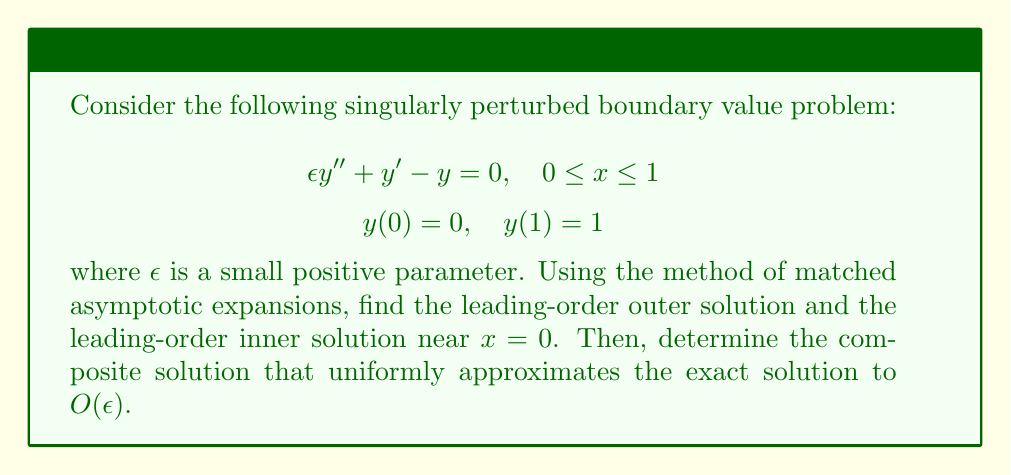What is the answer to this math problem? To solve this problem using matched asymptotic expansions, we'll follow these steps:

1) Outer solution:
Set $\epsilon = 0$ in the original equation to get the reduced equation:
$$y' - y = 0$$
The general solution is $y_{out} = Ae^x$. Applying the boundary condition at $x = 1$:
$$y_{out}(1) = Ae^1 = 1 \implies A = e^{-1}$$
So the outer solution is:
$$y_{out} = e^{x-1}$$

2) Inner solution:
Near $x = 0$, introduce a stretched coordinate $X = x/\epsilon$. The equation becomes:
$$\frac{d^2y}{dX^2} + \frac{dy}{dX} - \epsilon y = 0$$
To leading order as $\epsilon \to 0$:
$$\frac{d^2y}{dX^2} + \frac{dy}{dX} = 0$$
The general solution is:
$$y_{in} = B + Ce^{-X}$$
Applying the boundary condition at $x = 0$ (i.e., $X = 0$):
$$y_{in}(0) = B + C = 0 \implies C = -B$$
So the inner solution is:
$$y_{in} = B(1 - e^{-X}) = B(1 - e^{-x/\epsilon})$$

3) Matching:
To determine $B$, we match the inner and outer solutions in an intermediate region where both are valid. As $X \to \infty$ (or $x/\epsilon \to \infty$):
$$y_{in} \sim B$$
As $x \to 0$:
$$y_{out} \sim e^{-1}(1 + x)$$
Matching these:
$$B = e^{-1}$$

4) Composite solution:
The composite solution is formed by adding the inner and outer solutions and subtracting their common part:
$$y_{comp} = y_{in} + y_{out} - y_{common}$$
$$= e^{-1}(1 - e^{-x/\epsilon}) + e^{x-1} - e^{-1}$$
$$= e^{x-1} - e^{-1}e^{-x/\epsilon}$$

This composite solution uniformly approximates the exact solution to $O(\epsilon)$ throughout the domain.
Answer: The composite solution that uniformly approximates the exact solution to $O(\epsilon)$ is:

$$y_{comp} = e^{x-1} - e^{-1}e^{-x/\epsilon}$$ 